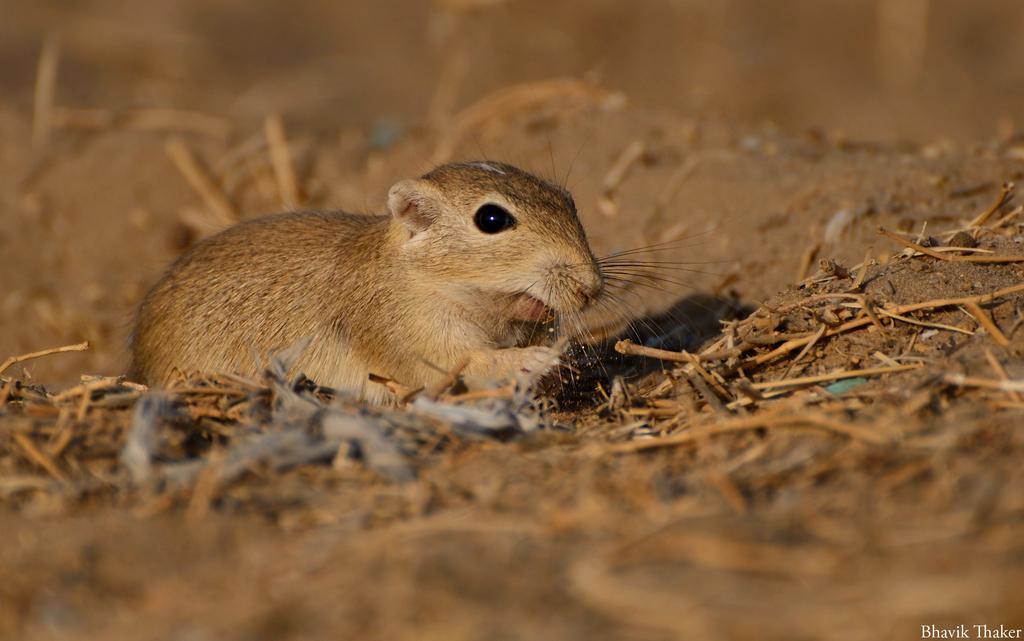How would you summarize this image in a sentence or two? In this image I can see the mouse which is in brown color. It is on the ground. On the ground there are some sticks. And there is a blurred background. 